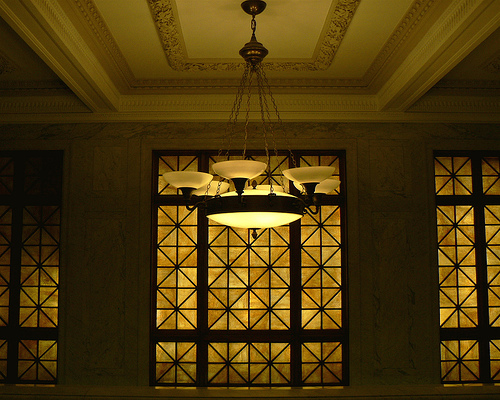<image>
Can you confirm if the outer lamp is above the main lamp? No. The outer lamp is not positioned above the main lamp. The vertical arrangement shows a different relationship. 